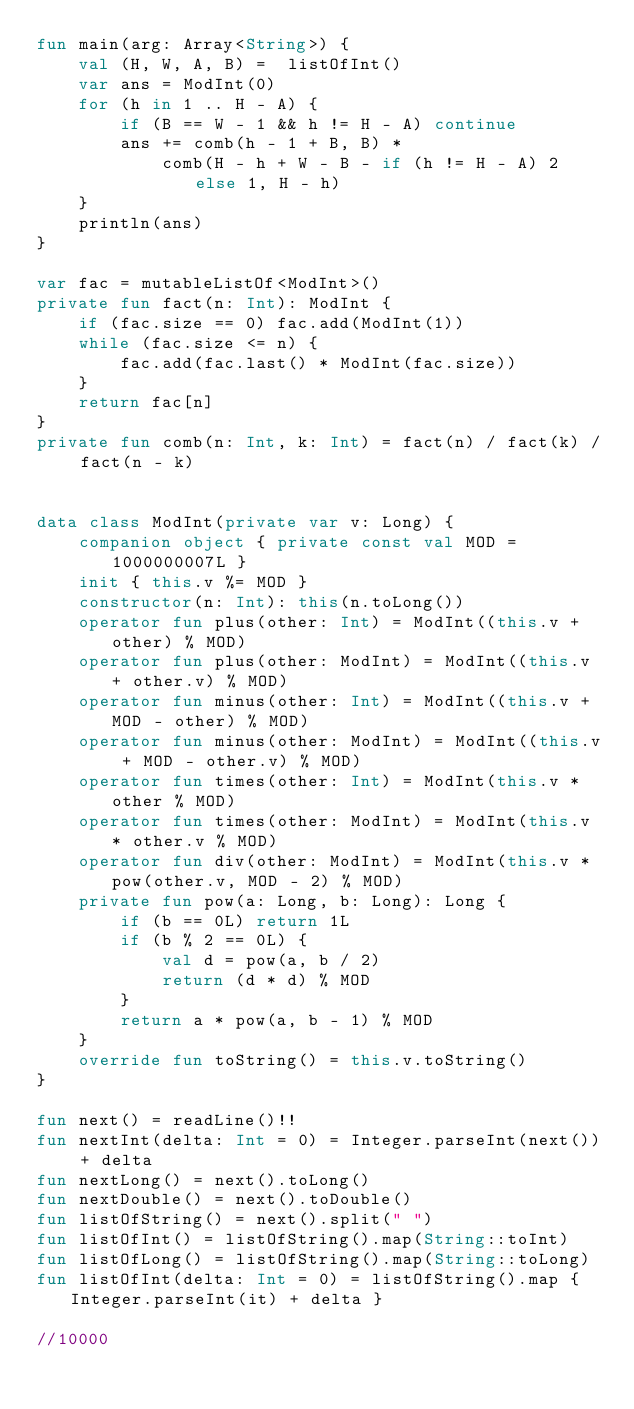<code> <loc_0><loc_0><loc_500><loc_500><_Kotlin_>fun main(arg: Array<String>) {
    val (H, W, A, B) =  listOfInt()
    var ans = ModInt(0)
    for (h in 1 .. H - A) {
        if (B == W - 1 && h != H - A) continue
        ans += comb(h - 1 + B, B) *
            comb(H - h + W - B - if (h != H - A) 2 else 1, H - h)
    }
    println(ans)
}

var fac = mutableListOf<ModInt>()
private fun fact(n: Int): ModInt {
    if (fac.size == 0) fac.add(ModInt(1))
    while (fac.size <= n) {
        fac.add(fac.last() * ModInt(fac.size))
    }
    return fac[n]
}
private fun comb(n: Int, k: Int) = fact(n) / fact(k) / fact(n - k)


data class ModInt(private var v: Long) {
    companion object { private const val MOD = 1000000007L }
    init { this.v %= MOD }
    constructor(n: Int): this(n.toLong())
    operator fun plus(other: Int) = ModInt((this.v + other) % MOD)
    operator fun plus(other: ModInt) = ModInt((this.v + other.v) % MOD)
    operator fun minus(other: Int) = ModInt((this.v + MOD - other) % MOD)
    operator fun minus(other: ModInt) = ModInt((this.v + MOD - other.v) % MOD)
    operator fun times(other: Int) = ModInt(this.v * other % MOD)
    operator fun times(other: ModInt) = ModInt(this.v * other.v % MOD)
    operator fun div(other: ModInt) = ModInt(this.v * pow(other.v, MOD - 2) % MOD)
    private fun pow(a: Long, b: Long): Long {
        if (b == 0L) return 1L
        if (b % 2 == 0L) {
            val d = pow(a, b / 2)
            return (d * d) % MOD
        }
        return a * pow(a, b - 1) % MOD
    }
    override fun toString() = this.v.toString()
}

fun next() = readLine()!!
fun nextInt(delta: Int = 0) = Integer.parseInt(next()) + delta
fun nextLong() = next().toLong()
fun nextDouble() = next().toDouble()
fun listOfString() = next().split(" ")
fun listOfInt() = listOfString().map(String::toInt)
fun listOfLong() = listOfString().map(String::toLong)
fun listOfInt(delta: Int = 0) = listOfString().map { Integer.parseInt(it) + delta }

//10000
</code> 